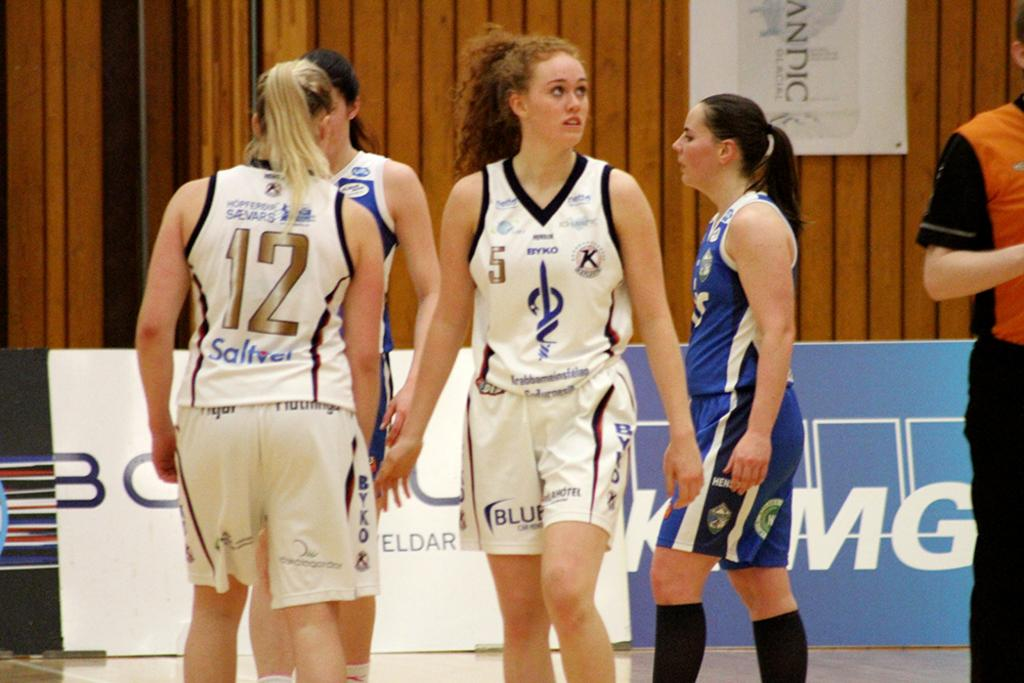<image>
Share a concise interpretation of the image provided. Woman wearing a basketball jersey that says  5 on it. 